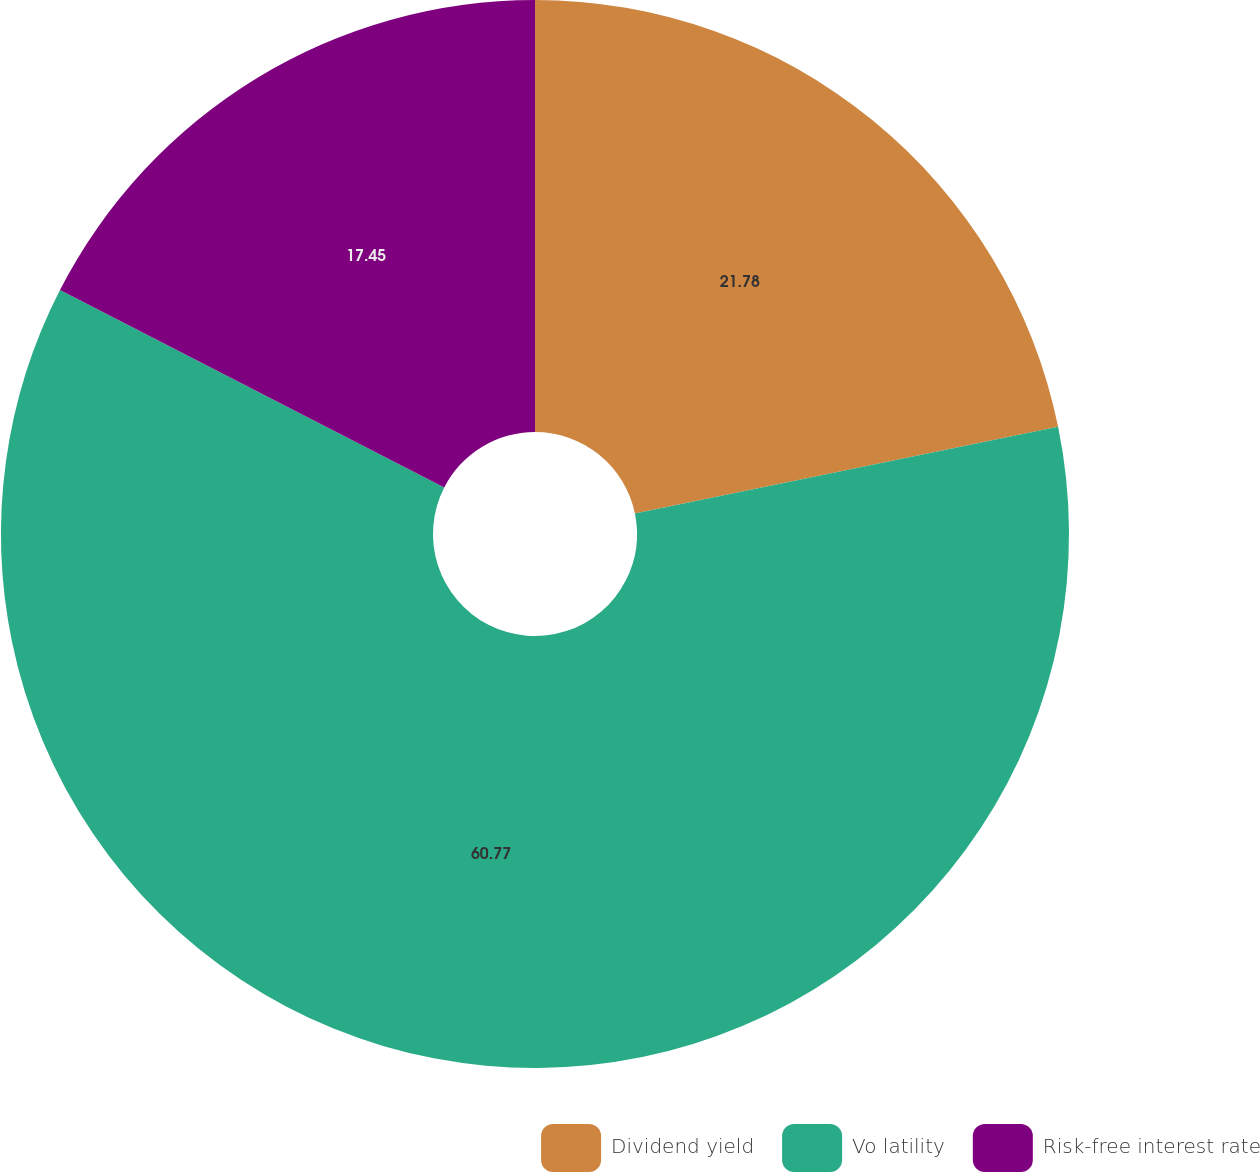<chart> <loc_0><loc_0><loc_500><loc_500><pie_chart><fcel>Dividend yield<fcel>Vo latility<fcel>Risk-free interest rate<nl><fcel>21.78%<fcel>60.77%<fcel>17.45%<nl></chart> 